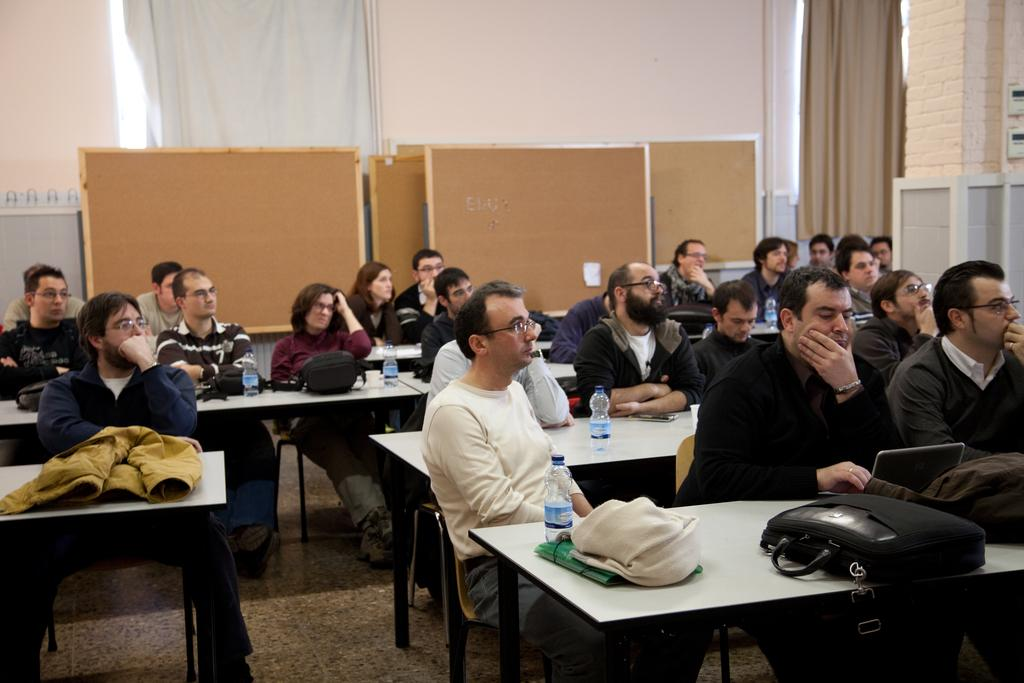What are the people in the image doing? The people in the image are sitting on chairs. What objects are in front of the chairs? There are tables in front of the chairs. What can be seen on the tables? There are water bottles and bags on the tables. Where is the playground located in the image? There is no playground present in the image. How many times do the people in the image sneeze? There is no indication of anyone sneezing in the image. 